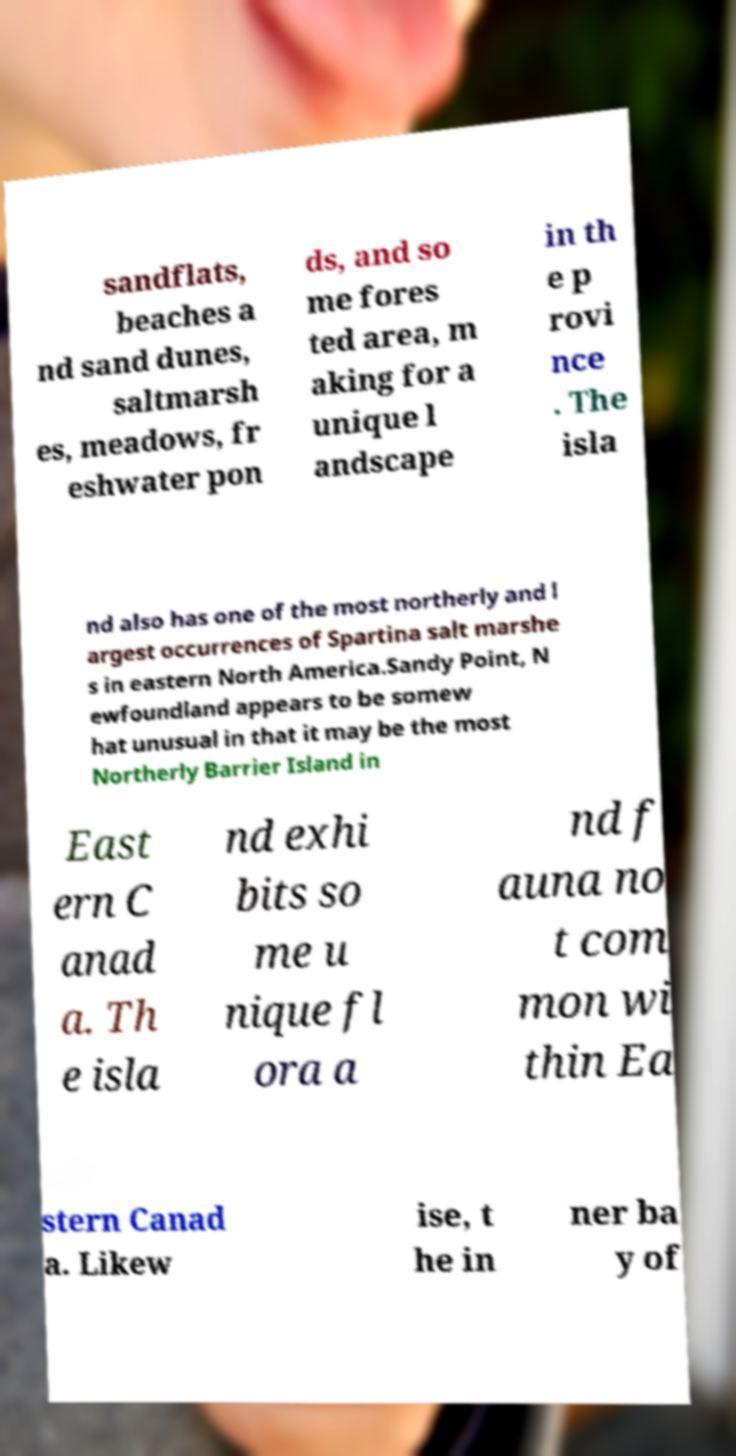Can you accurately transcribe the text from the provided image for me? sandflats, beaches a nd sand dunes, saltmarsh es, meadows, fr eshwater pon ds, and so me fores ted area, m aking for a unique l andscape in th e p rovi nce . The isla nd also has one of the most northerly and l argest occurrences of Spartina salt marshe s in eastern North America.Sandy Point, N ewfoundland appears to be somew hat unusual in that it may be the most Northerly Barrier Island in East ern C anad a. Th e isla nd exhi bits so me u nique fl ora a nd f auna no t com mon wi thin Ea stern Canad a. Likew ise, t he in ner ba y of 